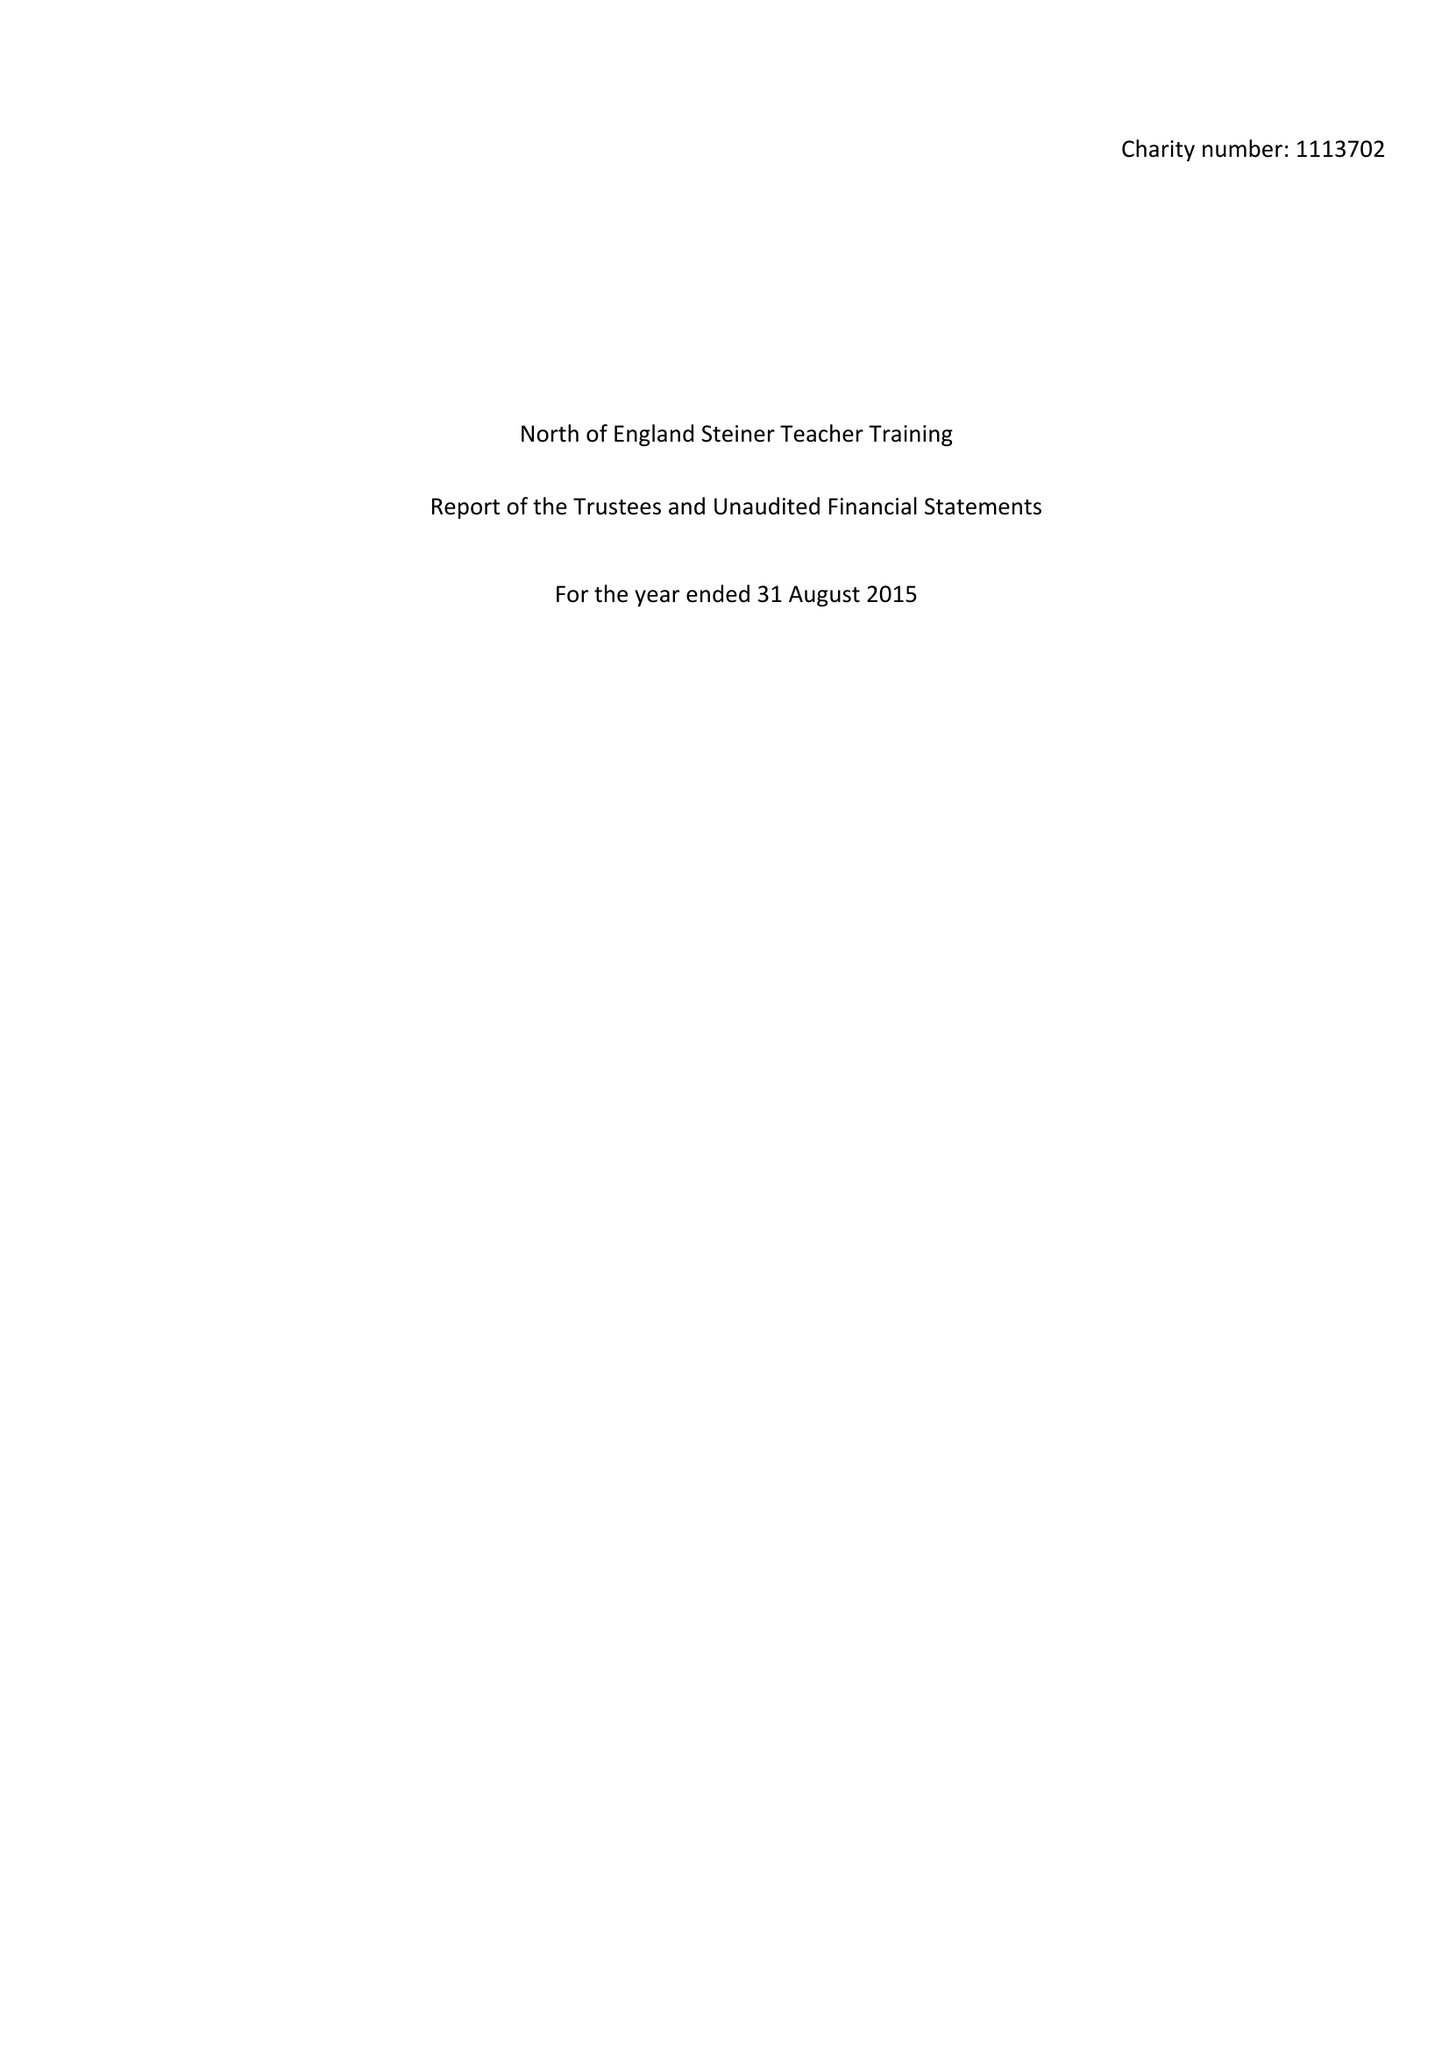What is the value for the income_annually_in_british_pounds?
Answer the question using a single word or phrase. 66402.00 